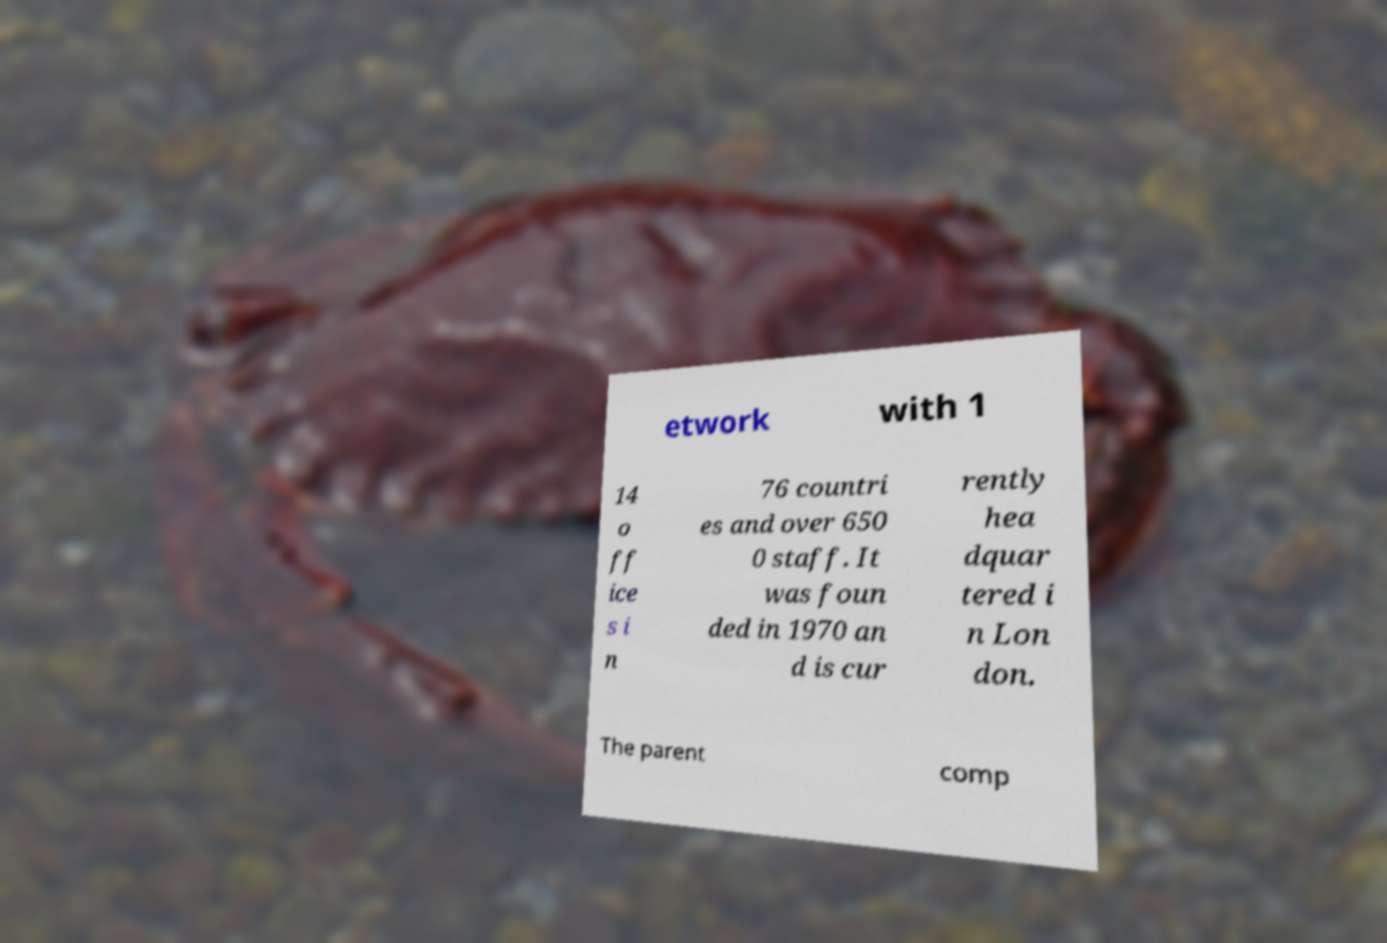Could you extract and type out the text from this image? etwork with 1 14 o ff ice s i n 76 countri es and over 650 0 staff. It was foun ded in 1970 an d is cur rently hea dquar tered i n Lon don. The parent comp 